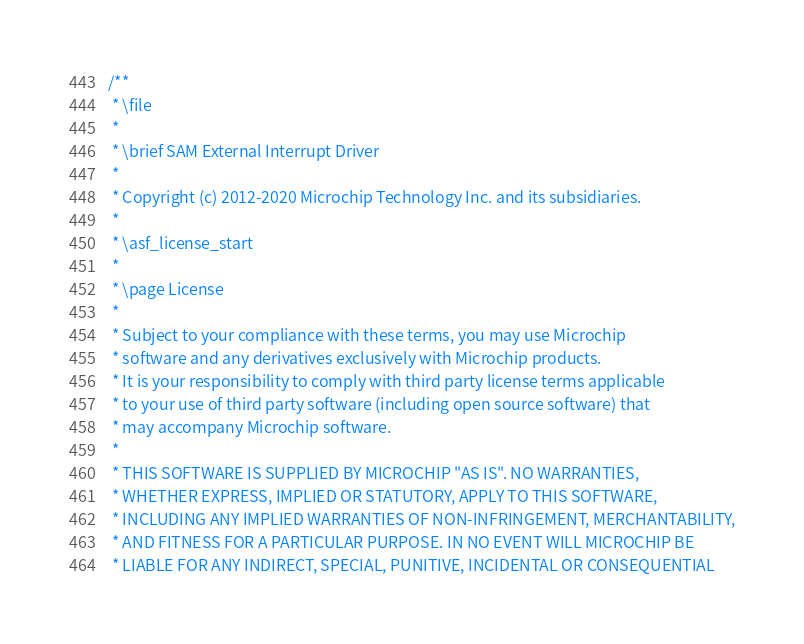<code> <loc_0><loc_0><loc_500><loc_500><_C_>/**
 * \file
 *
 * \brief SAM External Interrupt Driver
 *
 * Copyright (c) 2012-2020 Microchip Technology Inc. and its subsidiaries.
 *
 * \asf_license_start
 *
 * \page License
 *
 * Subject to your compliance with these terms, you may use Microchip
 * software and any derivatives exclusively with Microchip products.
 * It is your responsibility to comply with third party license terms applicable
 * to your use of third party software (including open source software) that
 * may accompany Microchip software.
 *
 * THIS SOFTWARE IS SUPPLIED BY MICROCHIP "AS IS". NO WARRANTIES,
 * WHETHER EXPRESS, IMPLIED OR STATUTORY, APPLY TO THIS SOFTWARE,
 * INCLUDING ANY IMPLIED WARRANTIES OF NON-INFRINGEMENT, MERCHANTABILITY,
 * AND FITNESS FOR A PARTICULAR PURPOSE. IN NO EVENT WILL MICROCHIP BE
 * LIABLE FOR ANY INDIRECT, SPECIAL, PUNITIVE, INCIDENTAL OR CONSEQUENTIAL</code> 